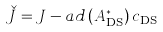<formula> <loc_0><loc_0><loc_500><loc_500>\check { J } = J - a d \left ( A ^ { * } _ { \text {DS} } \right ) c _ { \text {DS} }</formula> 